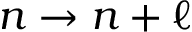<formula> <loc_0><loc_0><loc_500><loc_500>n \to n + \ell</formula> 